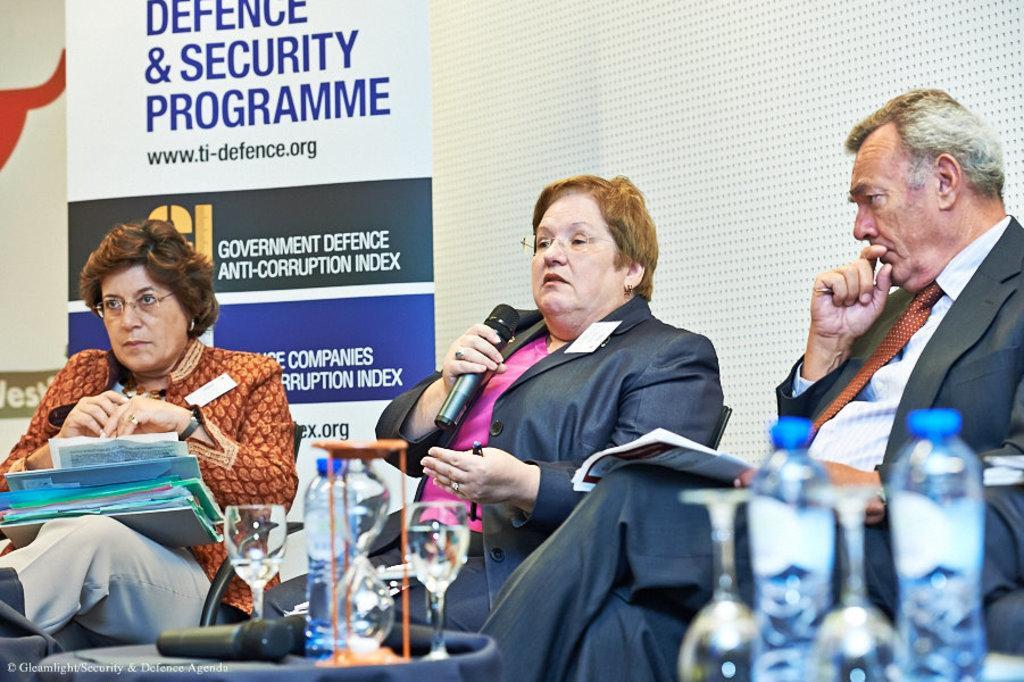Please provide a concise description of this image. In the picture I can see three people are sitting on chairs. Among them the woman in the middle is holding a microphone in the hand. In the background I can see a banner on which something written on it. In front of the image I can see bottles, glass and some other objects. 